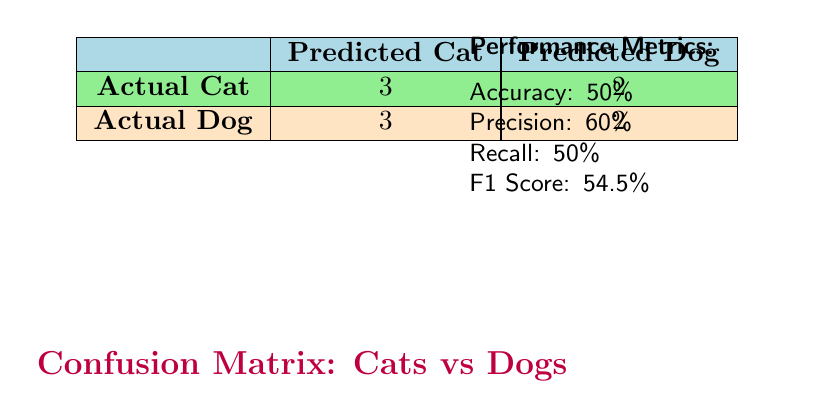What is the number of true positive classifications for cats? The number of true positive classifications for cats is represented in the confusion matrix under "Actual Cat" and "Predicted Cat," which shows a value of 3. This indicates that there are 3 instances where cats were correctly identified as cats.
Answer: 3 How many false negatives were there in the classification? The number of false negatives is found in the confusion matrix under "Actual Cat" and "Predicted Dog," which shows a value of 2. This means there were 2 instances where actual cats were incorrectly classified as dogs.
Answer: 2 What is the precision of the model? Precision is calculated as the number of true positives divided by the sum of true positives and false positives. Here, precision = 3 / (3 + 2) = 0.6. This indicates the model's accuracy in predicting positive labels.
Answer: 0.6 Is the recall of the model higher than the precision? Recall is 0.5 and precision is 0.6, so recall is not higher than precision. This indicates that the model is better at precision than recall.
Answer: No What is the total number of instances classified as dogs? To find the total number of instances classified as dogs, we look at the sum of true positives for dogs (2) and false positives for dogs (3), which gives us a total of 5.
Answer: 5 What is the accuracy percentage of the model? Accuracy is calculated as the sum of true positives and true negatives divided by the total number of instances. Here, accuracy = (3 + 2) / 10 = 0.5, which means the model correctly classified 50% of the instances.
Answer: 0.5 If the model had classified all images as dogs, how many cats would it incorrectly classify? If classified all as dogs, the model would classify all true cats incorrectly, which is the total number of actual cats (5) since it only identified 3 correctly. So that gives 5 - 3 = 2 cats would be misclassified.
Answer: 5 What is the F1 score of the model? The F1 score is calculated using the formula: 2 * (precision * recall) / (precision + recall). Here, it is 2 * (0.6 * 0.5) / (0.6 + 0.5) = 0.545, indicating a balance between precision and recall.
Answer: 0.545 How many dogs did the model incorrectly classify as cats? The number of dogs incorrectly classified as cats is indicated in the confusion matrix under "Actual Dog" and "Predicted Cat," which shows a value of 3. This means there are 3 instances where dogs were incorrectly identified as cats.
Answer: 3 